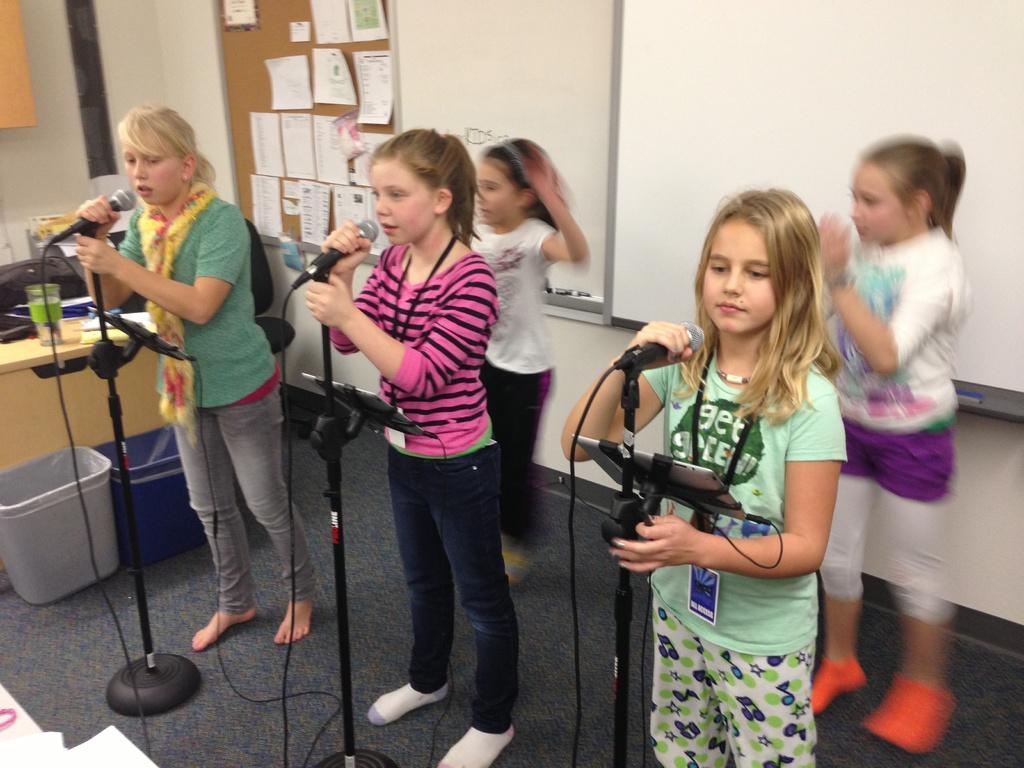Could you give a brief overview of what you see in this image? In this pictures we can see and people standing on the floor and holding the mic and singing. 